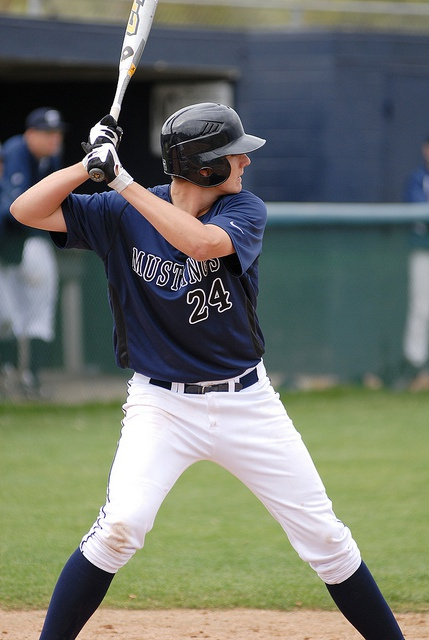Describe the objects in this image and their specific colors. I can see people in gray, lavender, black, navy, and tan tones, people in gray, darkgray, black, and darkblue tones, and baseball bat in gray, white, darkgray, and black tones in this image. 